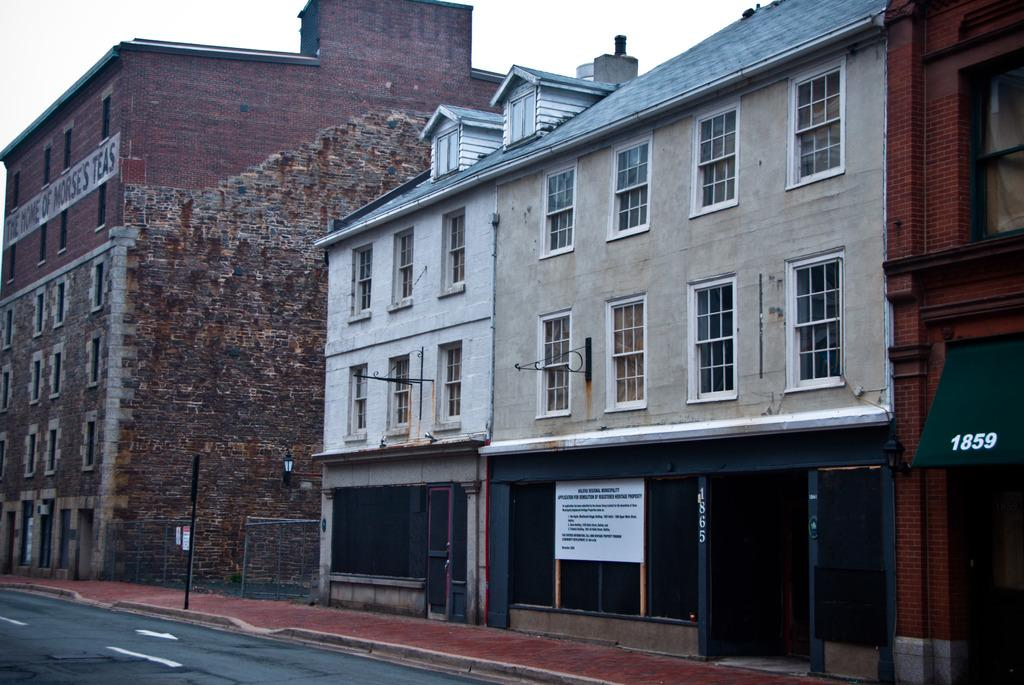What can be seen near the footpath in the image? There is a road near the footpath in the image. What is located on the road in the image? There is a pole on the road. What type of buildings are visible on the right side of the image? There are buildings with glass windows on the right side of the image. What is visible in the background of the image? The background of the image includes a blue sky. How many cows are attacking the pole in the image? There are no cows or attacks present in the image. What type of earth is visible in the image? The image does not show any specific type of earth; it only shows a road, a pole, buildings, and a blue sky. 